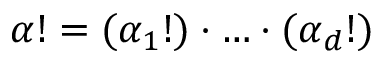<formula> <loc_0><loc_0><loc_500><loc_500>{ \alpha } ! = ( \alpha _ { 1 } ! ) \cdot \dots \cdot ( \alpha _ { d } ! )</formula> 